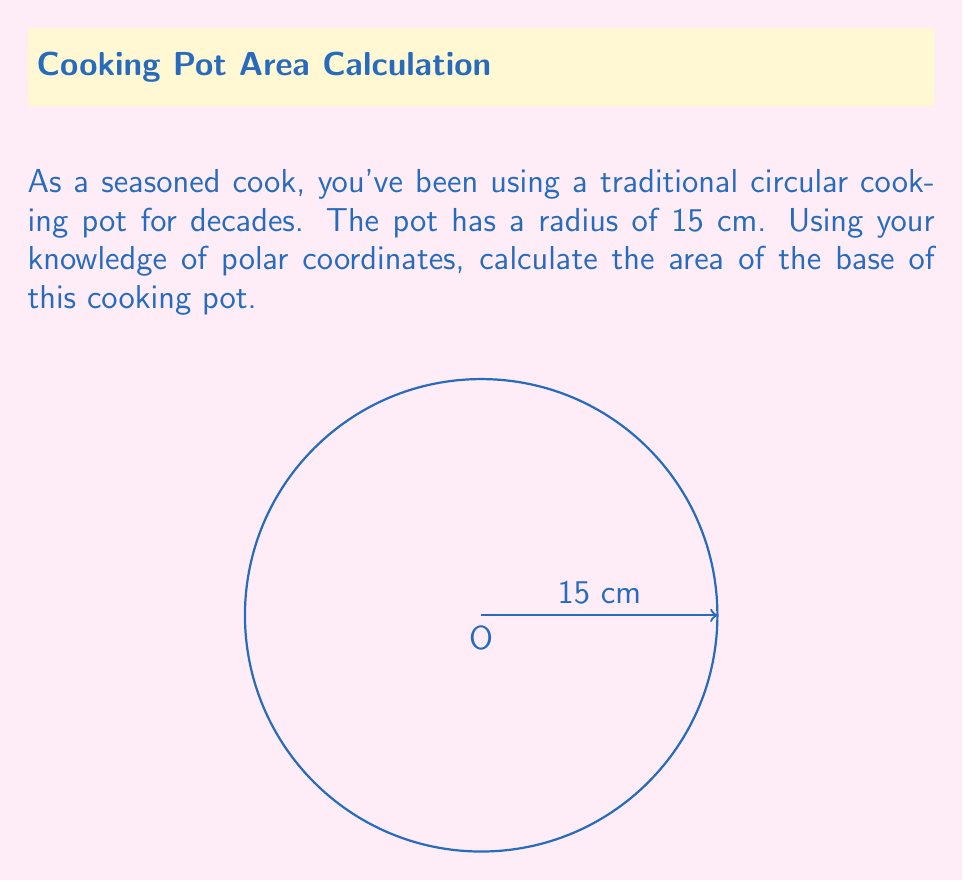Show me your answer to this math problem. To calculate the area of the circular base of the cooking pot using polar coordinates, we follow these steps:

1) In polar coordinates, the equation of a circle centered at the origin is $r = R$, where $R$ is the radius of the circle.

2) The formula for the area of a region in polar coordinates is:

   $$A = \frac{1}{2} \int_{\theta_1}^{\theta_2} r^2 d\theta$$

3) For a full circle, we integrate from 0 to $2\pi$:

   $$A = \frac{1}{2} \int_{0}^{2\pi} r^2 d\theta$$

4) In our case, $r = R = 15$ cm (constant), so we can take it out of the integral:

   $$A = \frac{1}{2} (15)^2 \int_{0}^{2\pi} d\theta$$

5) Evaluate the integral:

   $$A = \frac{1}{2} (15)^2 [2\pi - 0] = \frac{1}{2} (225) (2\pi) = 225\pi$$

6) Therefore, the area of the base of the cooking pot is $225\pi$ square centimeters.
Answer: $225\pi$ cm² 